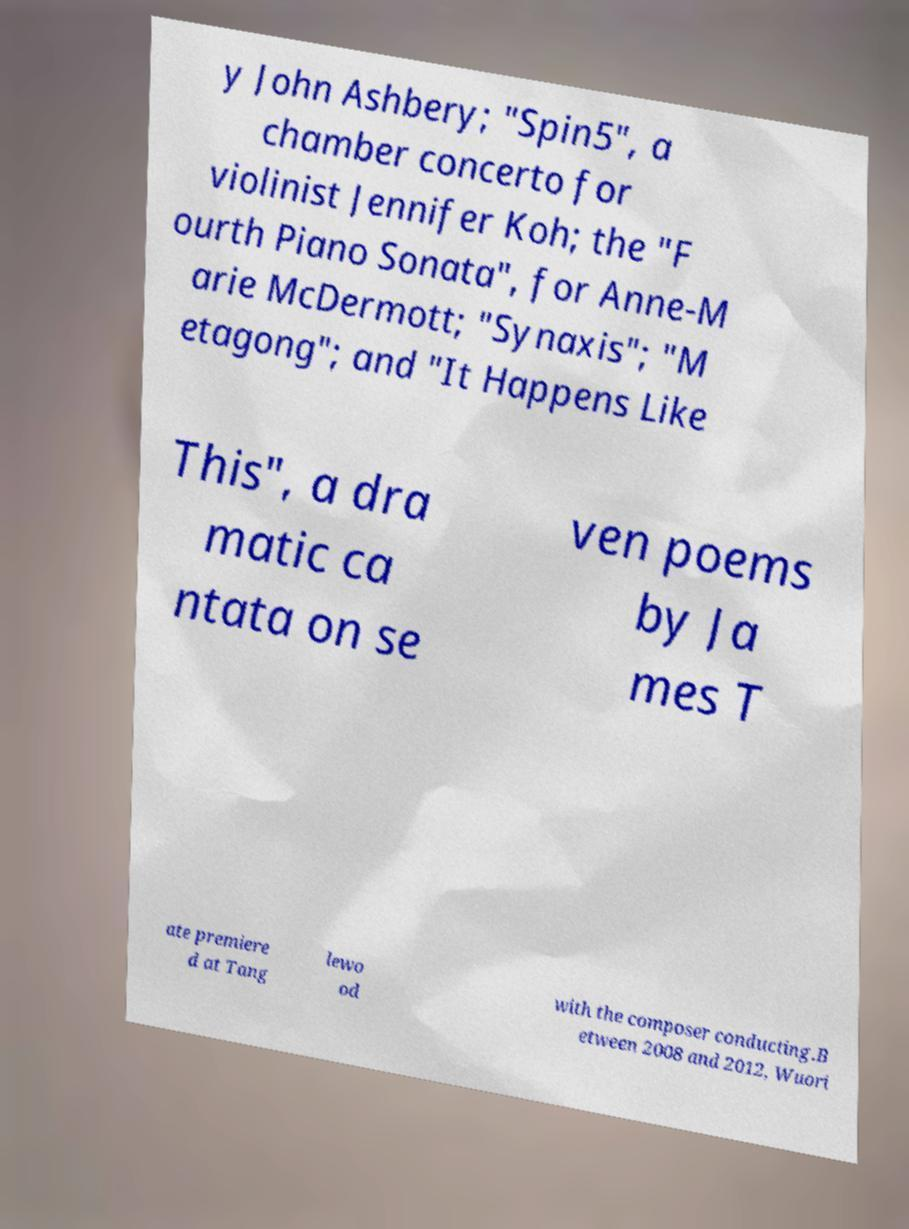Could you assist in decoding the text presented in this image and type it out clearly? y John Ashbery; "Spin5", a chamber concerto for violinist Jennifer Koh; the "F ourth Piano Sonata", for Anne-M arie McDermott; "Synaxis"; "M etagong"; and "It Happens Like This", a dra matic ca ntata on se ven poems by Ja mes T ate premiere d at Tang lewo od with the composer conducting.B etween 2008 and 2012, Wuori 